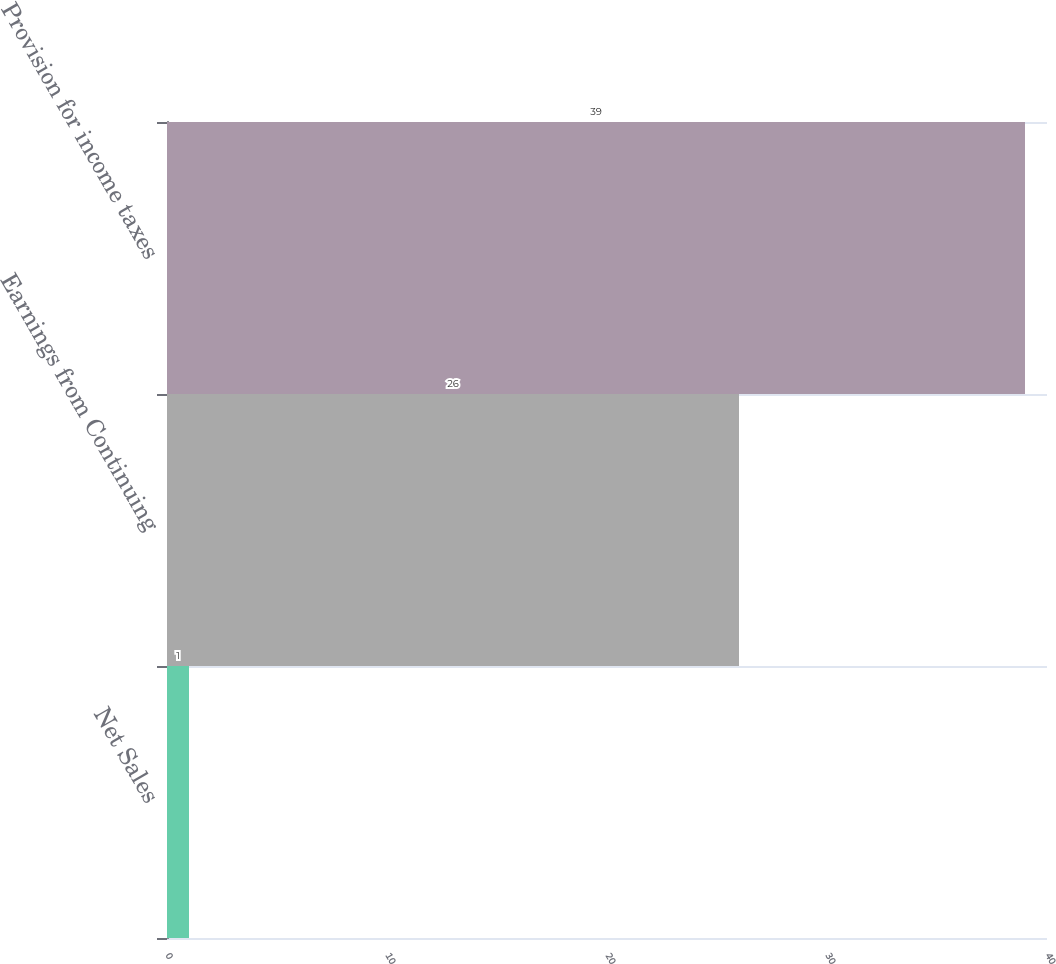<chart> <loc_0><loc_0><loc_500><loc_500><bar_chart><fcel>Net Sales<fcel>Earnings from Continuing<fcel>Provision for income taxes<nl><fcel>1<fcel>26<fcel>39<nl></chart> 